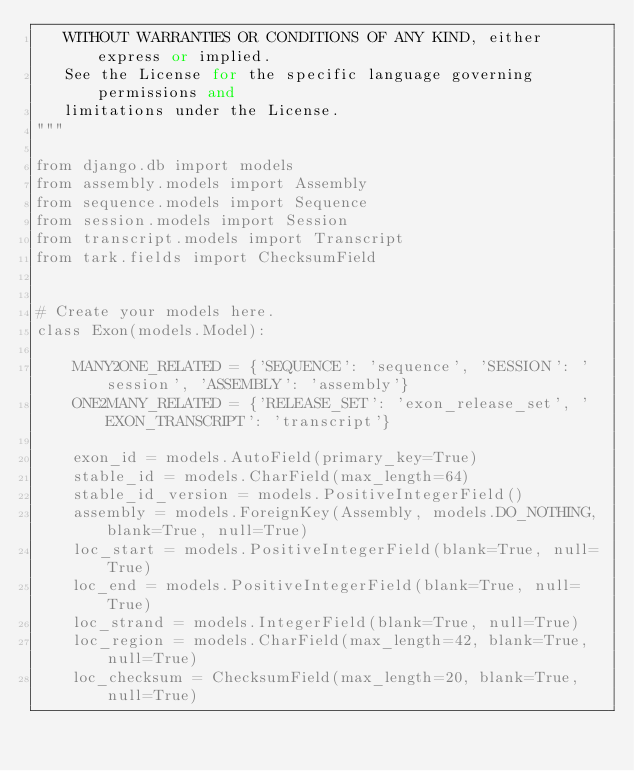Convert code to text. <code><loc_0><loc_0><loc_500><loc_500><_Python_>   WITHOUT WARRANTIES OR CONDITIONS OF ANY KIND, either express or implied.
   See the License for the specific language governing permissions and
   limitations under the License.
"""

from django.db import models
from assembly.models import Assembly
from sequence.models import Sequence
from session.models import Session
from transcript.models import Transcript
from tark.fields import ChecksumField


# Create your models here.
class Exon(models.Model):

    MANY2ONE_RELATED = {'SEQUENCE': 'sequence', 'SESSION': 'session', 'ASSEMBLY': 'assembly'}
    ONE2MANY_RELATED = {'RELEASE_SET': 'exon_release_set', 'EXON_TRANSCRIPT': 'transcript'}

    exon_id = models.AutoField(primary_key=True)
    stable_id = models.CharField(max_length=64)
    stable_id_version = models.PositiveIntegerField()
    assembly = models.ForeignKey(Assembly, models.DO_NOTHING, blank=True, null=True)
    loc_start = models.PositiveIntegerField(blank=True, null=True)
    loc_end = models.PositiveIntegerField(blank=True, null=True)
    loc_strand = models.IntegerField(blank=True, null=True)
    loc_region = models.CharField(max_length=42, blank=True, null=True)
    loc_checksum = ChecksumField(max_length=20, blank=True, null=True)</code> 